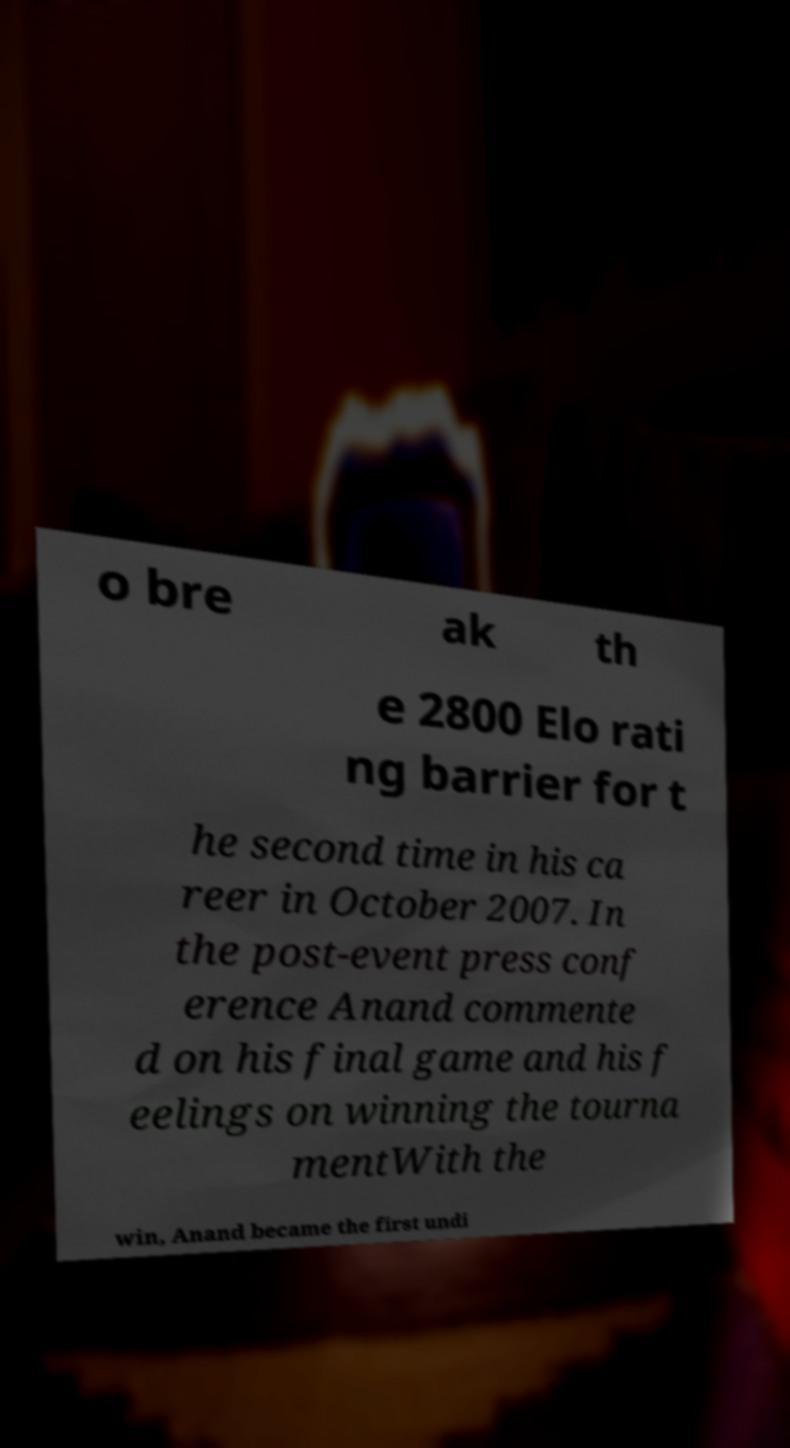Please read and relay the text visible in this image. What does it say? o bre ak th e 2800 Elo rati ng barrier for t he second time in his ca reer in October 2007. In the post-event press conf erence Anand commente d on his final game and his f eelings on winning the tourna mentWith the win, Anand became the first undi 